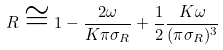<formula> <loc_0><loc_0><loc_500><loc_500>R \cong 1 - \frac { 2 \omega } { K \pi \sigma _ { R } } + \frac { 1 } { 2 } \frac { K \omega } { ( \pi \sigma _ { R } ) ^ { 3 } }</formula> 